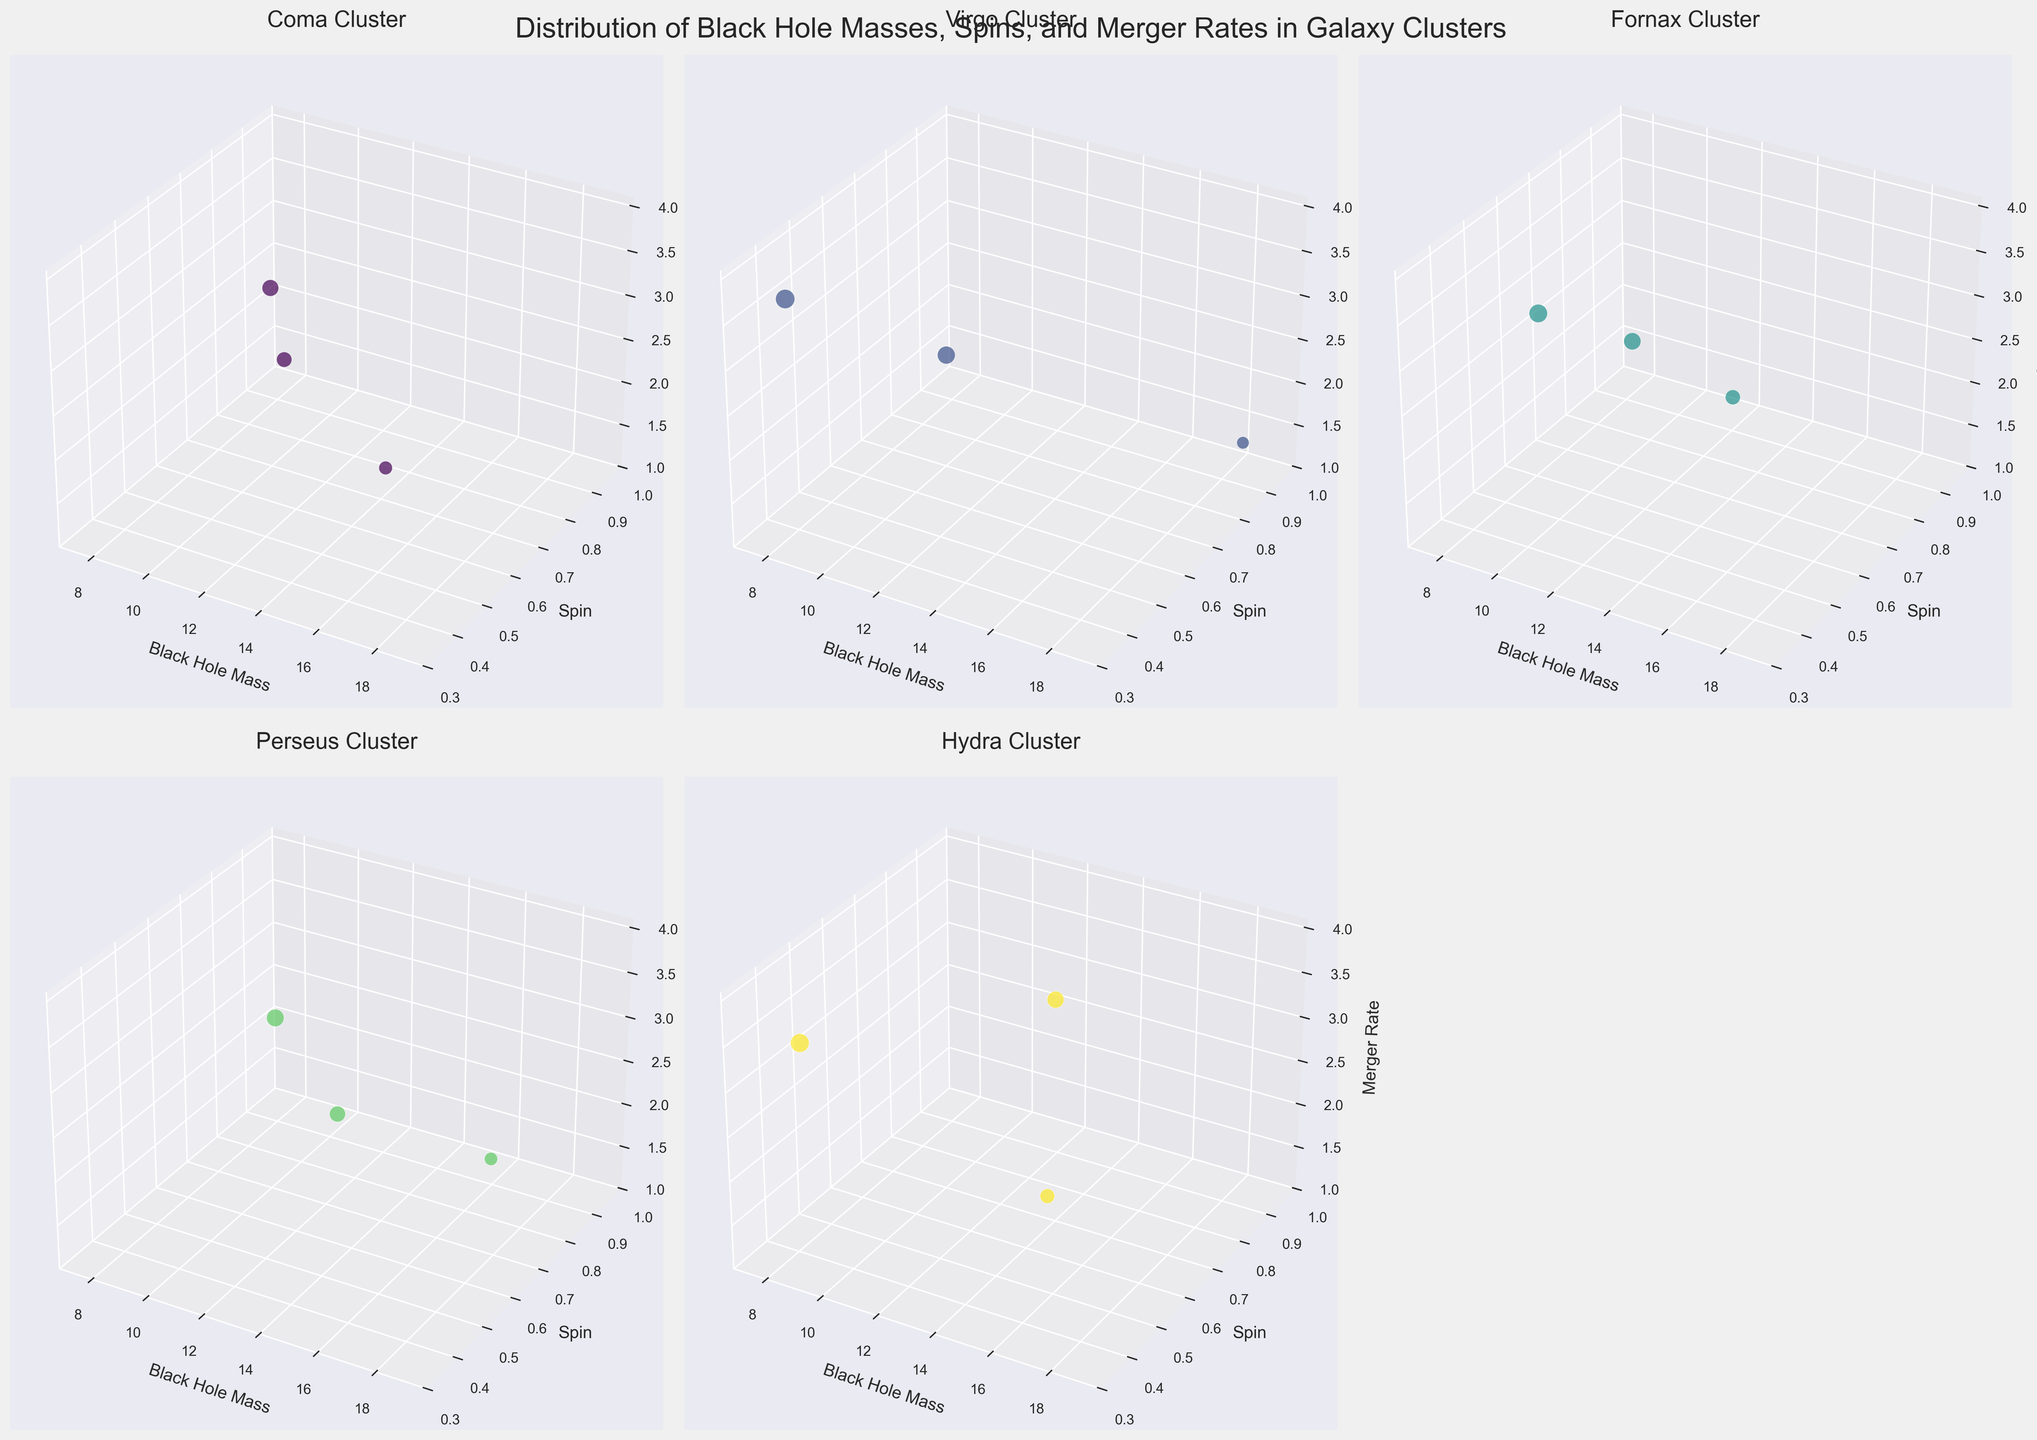What is the title of the figure? The title is located at the top of the figure and provides an overview of what the figure is depicting, which in this case is "Distribution of Black Hole Masses, Spins, and Merger Rates in Galaxy Clusters".
Answer: Distribution of Black Hole Masses, Spins, and Merger Rates in Galaxy Clusters What do the axes represent in each subplot? Axes labels describe what each dimension in the 3D plot represents: x-axis is 'Black Hole Mass', y-axis is 'Spin', and z-axis is 'Merger Rate'.
Answer: Black Hole Mass, Spin, Merger Rate Which cluster has the data point with the highest black hole mass and what are its coordinates in the plot? Checking all subplots for black hole masses, the Virgo Cluster has the highest value of 18.7 for black hole mass. The coordinates for this point in the plot are (18.7, 0.9, 1.5).
Answer: Virgo Cluster, (18.7, 0.9, 1.5) What is the minimum merger rate observed in the Hydra Cluster subplot? By looking at the merger rates in the Hydra Cluster, the lowest value is identified as 2.1.
Answer: 2.1 How does the black hole mass distribution in the Coma Cluster compare with the Virgo Cluster? Comparing the black hole mass data points in both clusters, the Coma Cluster ranges from 8.9 to 15.2, whereas the Virgo Cluster ranges from 7.8 to 18.7. The Virgo Cluster has a larger range and higher maximum value.
Answer: Virgo Cluster has a larger range and higher maximum value Which galaxy cluster has the most number of data points? Count the data points in each subplot. Coma Cluster, Virgo Cluster, Fornax Cluster, Perseus Cluster, and Hydra Cluster each have 3 data points, so they all have an equal number of data points.
Answer: All clusters have equal number of data points In which cluster is the average spin closest to 0.6? Calculate the average spin for each cluster: Coma Cluster (0.7 + 0.6 + 0.8)/3 = 0.7, Virgo Cluster (0.5 + 0.9 + 0.4)/3 ≈ 0.6, Fornax Cluster (0.6 + 0.7 + 0.5)/3 ≈ 0.6, Perseus Cluster (0.8 + 0.6 + 0.7)/3 ≈ 0.7, Hydra Cluster (0.5 + 0.9 + 0.4)/3 ≈ 0.6. So, Virgo Cluster, Fornax Cluster, and Hydra Cluster have an average spin closest to 0.6.
Answer: Virgo Cluster, Fornax Cluster, and Hydra Cluster What is the largest merger rate observed in the entire figure? Identify and compare the highest merger rate across all subplots. The highest value is 3.6 in the Virgo Cluster.
Answer: 3.6 